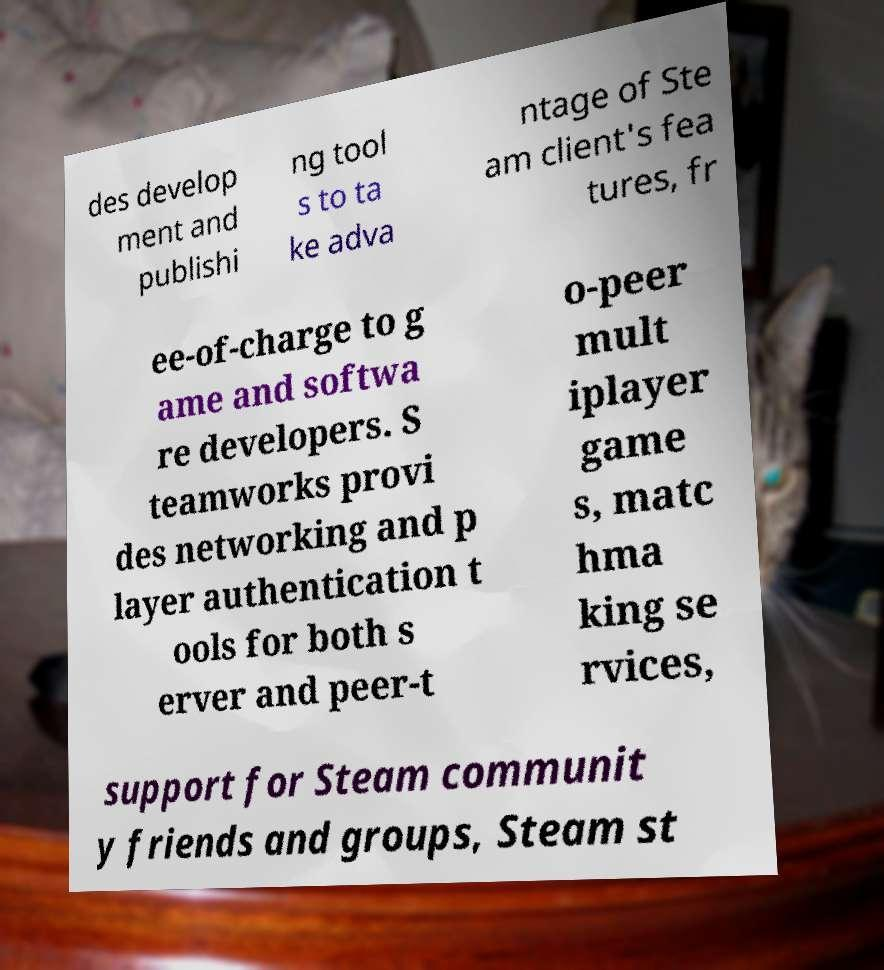Can you accurately transcribe the text from the provided image for me? des develop ment and publishi ng tool s to ta ke adva ntage of Ste am client's fea tures, fr ee-of-charge to g ame and softwa re developers. S teamworks provi des networking and p layer authentication t ools for both s erver and peer-t o-peer mult iplayer game s, matc hma king se rvices, support for Steam communit y friends and groups, Steam st 